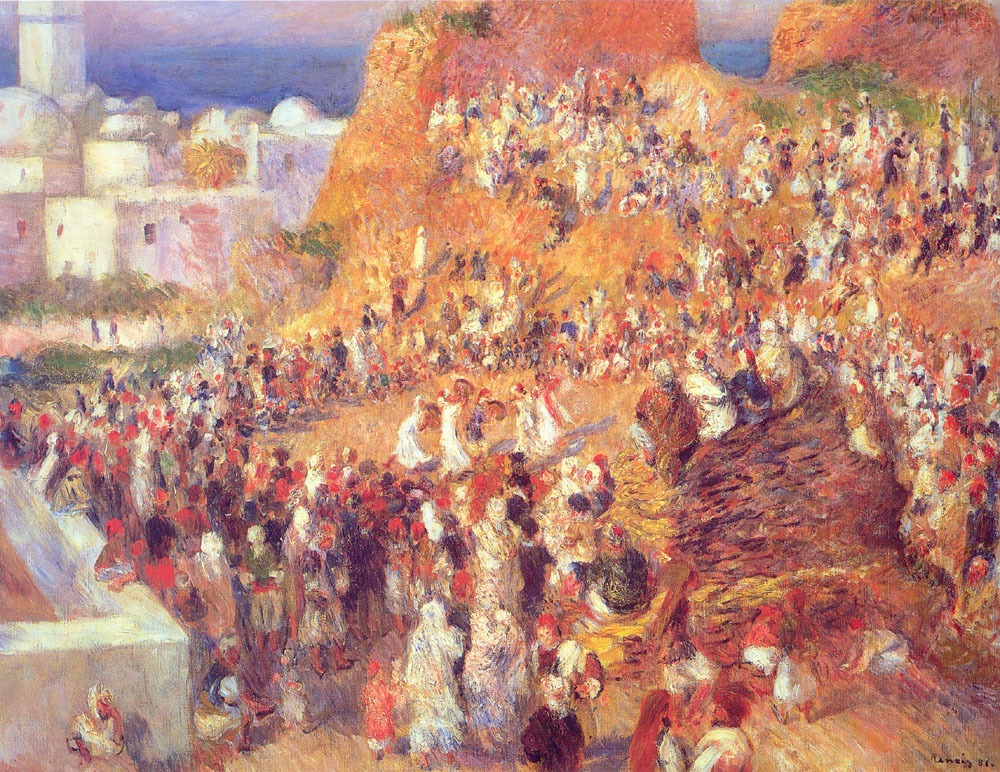What can you tell me about the architectural style visible in the background? The architecture in the background features buildings with flat rooftops and facades highlighted by sunlight, which is typical of Mediterranean regions. The structures indicate a warm climate and are likely made of materials such as stucco or stone, known for their ability to keep interiors cool. These architectural features, such as balconies and terraces, also suggest a social outdoor lifestyle inherent in Mediterranean culture. 